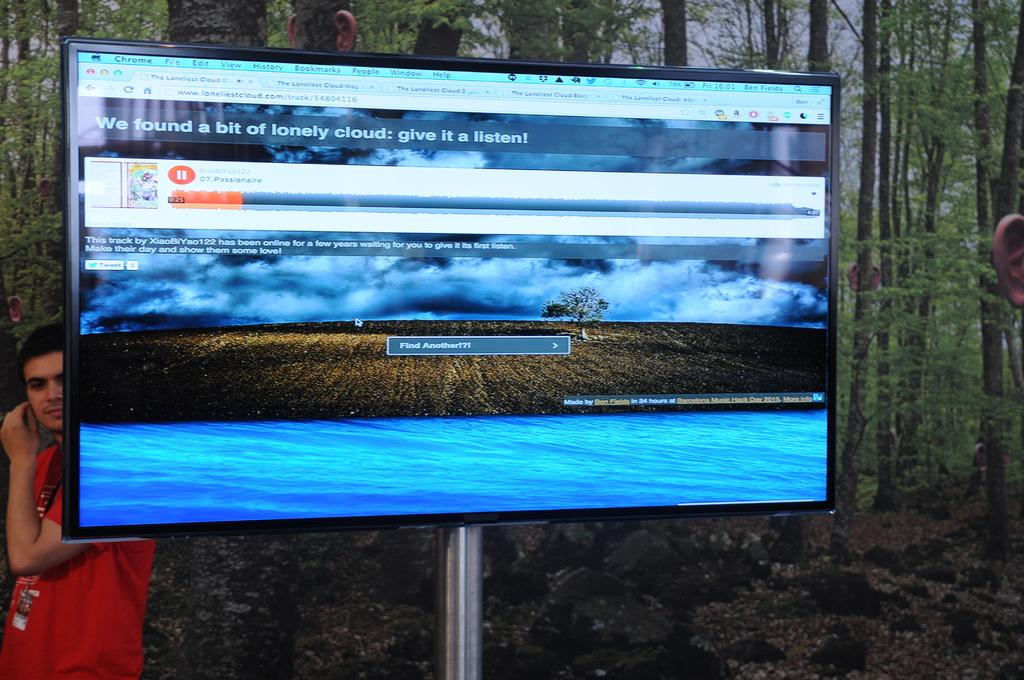Provide a one-sentence caption for the provided image. A television screen shows that the song Passionaire is playing. 